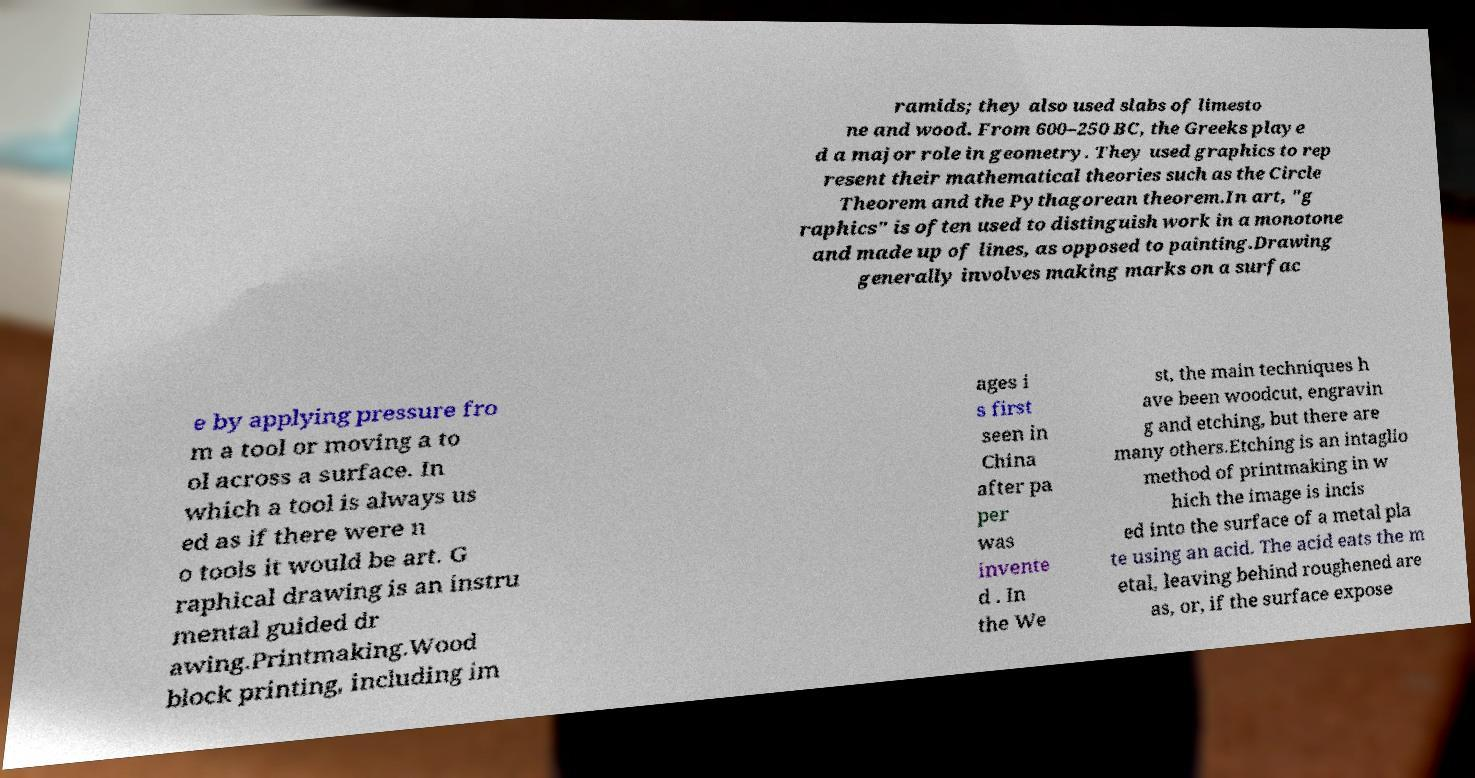Could you extract and type out the text from this image? ramids; they also used slabs of limesto ne and wood. From 600–250 BC, the Greeks playe d a major role in geometry. They used graphics to rep resent their mathematical theories such as the Circle Theorem and the Pythagorean theorem.In art, "g raphics" is often used to distinguish work in a monotone and made up of lines, as opposed to painting.Drawing generally involves making marks on a surfac e by applying pressure fro m a tool or moving a to ol across a surface. In which a tool is always us ed as if there were n o tools it would be art. G raphical drawing is an instru mental guided dr awing.Printmaking.Wood block printing, including im ages i s first seen in China after pa per was invente d . In the We st, the main techniques h ave been woodcut, engravin g and etching, but there are many others.Etching is an intaglio method of printmaking in w hich the image is incis ed into the surface of a metal pla te using an acid. The acid eats the m etal, leaving behind roughened are as, or, if the surface expose 